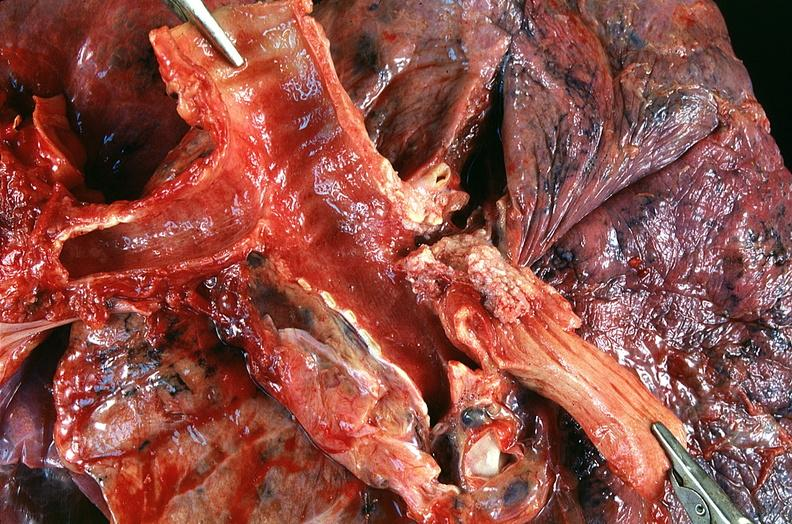where is this?
Answer the question using a single word or phrase. Lung 